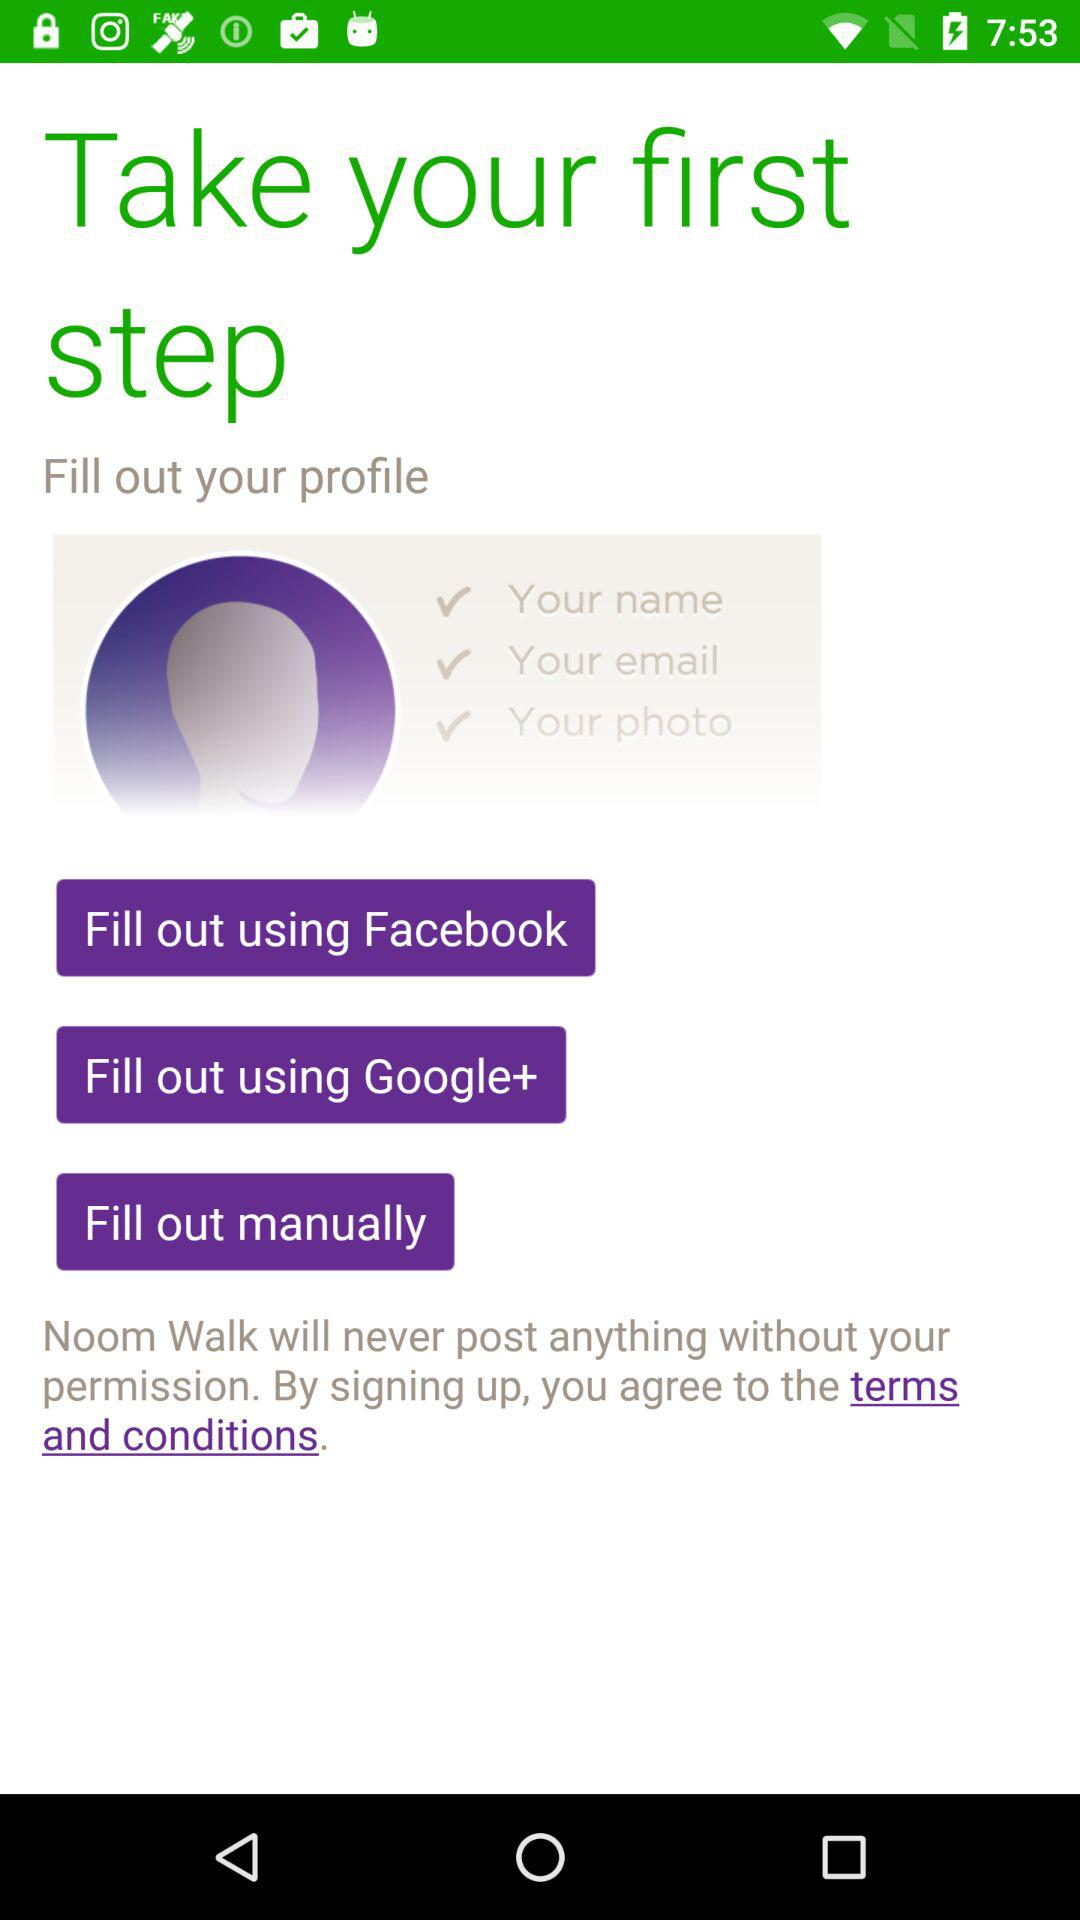How can we fill out the profile? You can fill out the profile using Facebook, Google+ or manually. 